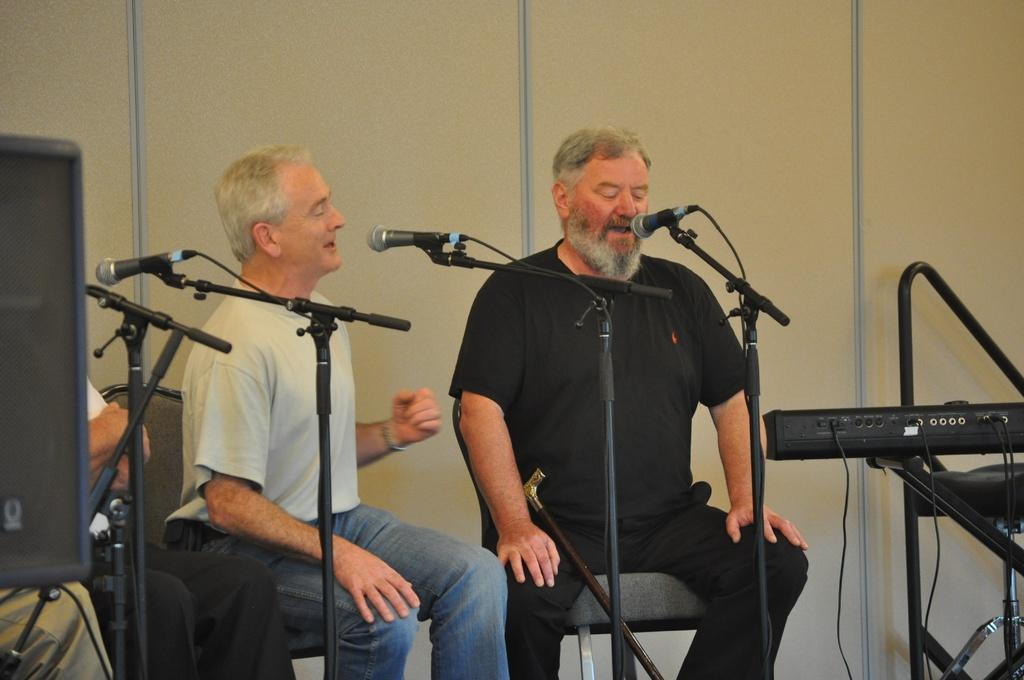How many people are in the image? There are two persons in the image. What are the persons doing in the image? The persons are singing. What objects are in the middle of the image? There are microphones in the middle of the image. What else can be seen in the image besides the persons and microphones? There are musical instruments in the image. How much water is present in the image? There is no water visible in the image. What type of grass can be seen growing near the persons in the image? There is no grass present in the image. 